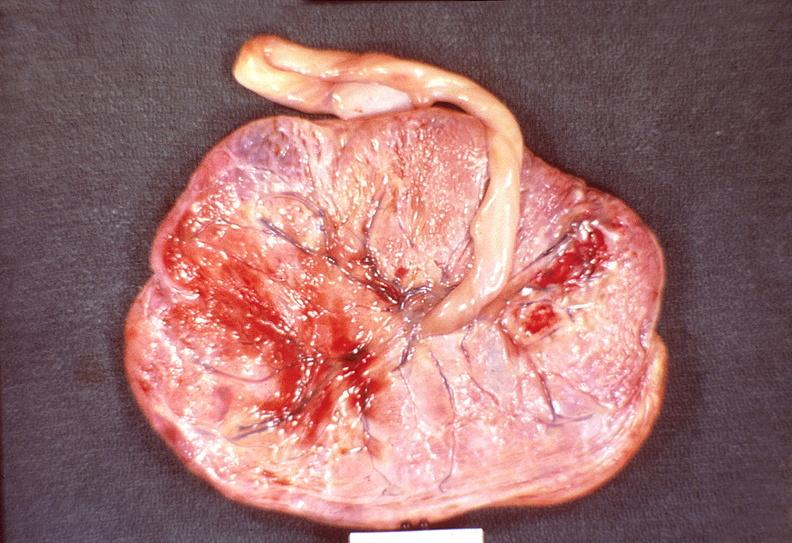where does this part belong to?
Answer the question using a single word or phrase. Female reproductive system 